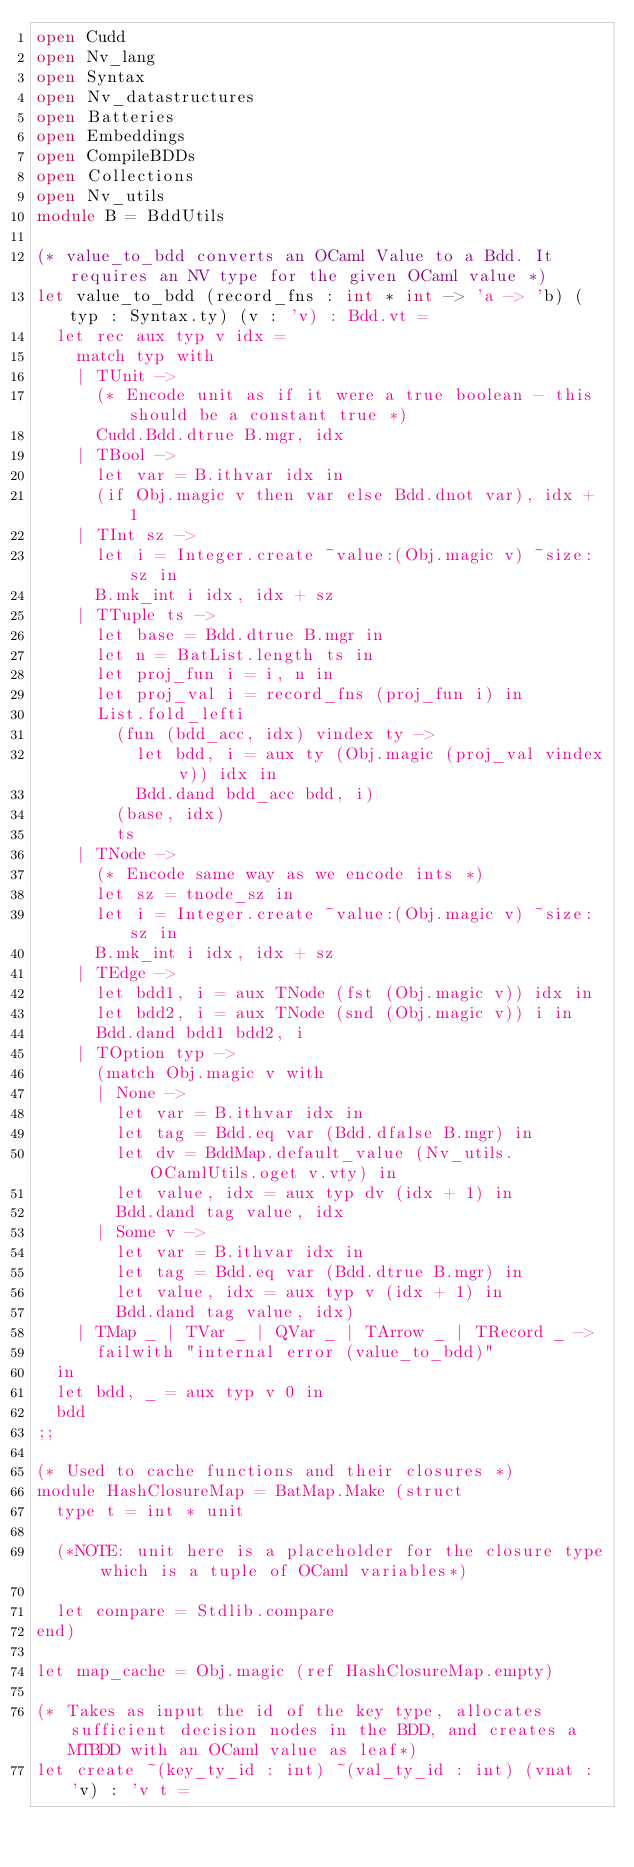Convert code to text. <code><loc_0><loc_0><loc_500><loc_500><_OCaml_>open Cudd
open Nv_lang
open Syntax
open Nv_datastructures
open Batteries
open Embeddings
open CompileBDDs
open Collections
open Nv_utils
module B = BddUtils

(* value_to_bdd converts an OCaml Value to a Bdd. It requires an NV type for the given OCaml value *)
let value_to_bdd (record_fns : int * int -> 'a -> 'b) (typ : Syntax.ty) (v : 'v) : Bdd.vt =
  let rec aux typ v idx =
    match typ with
    | TUnit ->
      (* Encode unit as if it were a true boolean - this should be a constant true *)
      Cudd.Bdd.dtrue B.mgr, idx
    | TBool ->
      let var = B.ithvar idx in
      (if Obj.magic v then var else Bdd.dnot var), idx + 1
    | TInt sz ->
      let i = Integer.create ~value:(Obj.magic v) ~size:sz in
      B.mk_int i idx, idx + sz
    | TTuple ts ->
      let base = Bdd.dtrue B.mgr in
      let n = BatList.length ts in
      let proj_fun i = i, n in
      let proj_val i = record_fns (proj_fun i) in
      List.fold_lefti
        (fun (bdd_acc, idx) vindex ty ->
          let bdd, i = aux ty (Obj.magic (proj_val vindex v)) idx in
          Bdd.dand bdd_acc bdd, i)
        (base, idx)
        ts
    | TNode ->
      (* Encode same way as we encode ints *)
      let sz = tnode_sz in
      let i = Integer.create ~value:(Obj.magic v) ~size:sz in
      B.mk_int i idx, idx + sz
    | TEdge ->
      let bdd1, i = aux TNode (fst (Obj.magic v)) idx in
      let bdd2, i = aux TNode (snd (Obj.magic v)) i in
      Bdd.dand bdd1 bdd2, i
    | TOption typ ->
      (match Obj.magic v with
      | None ->
        let var = B.ithvar idx in
        let tag = Bdd.eq var (Bdd.dfalse B.mgr) in
        let dv = BddMap.default_value (Nv_utils.OCamlUtils.oget v.vty) in
        let value, idx = aux typ dv (idx + 1) in
        Bdd.dand tag value, idx
      | Some v ->
        let var = B.ithvar idx in
        let tag = Bdd.eq var (Bdd.dtrue B.mgr) in
        let value, idx = aux typ v (idx + 1) in
        Bdd.dand tag value, idx)
    | TMap _ | TVar _ | QVar _ | TArrow _ | TRecord _ ->
      failwith "internal error (value_to_bdd)"
  in
  let bdd, _ = aux typ v 0 in
  bdd
;;

(* Used to cache functions and their closures *)
module HashClosureMap = BatMap.Make (struct
  type t = int * unit

  (*NOTE: unit here is a placeholder for the closure type which is a tuple of OCaml variables*)

  let compare = Stdlib.compare
end)

let map_cache = Obj.magic (ref HashClosureMap.empty)

(* Takes as input the id of the key type, allocates sufficient decision nodes in the BDD, and creates a MTBDD with an OCaml value as leaf*)
let create ~(key_ty_id : int) ~(val_ty_id : int) (vnat : 'v) : 'v t =</code> 